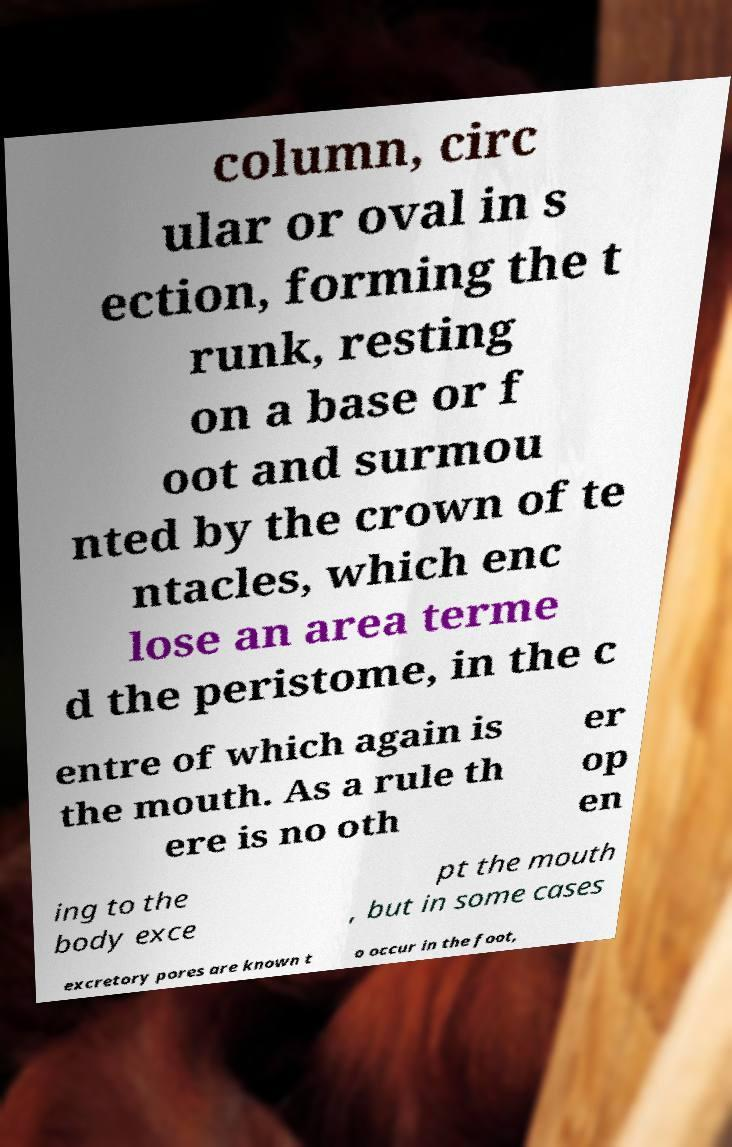Can you read and provide the text displayed in the image?This photo seems to have some interesting text. Can you extract and type it out for me? column, circ ular or oval in s ection, forming the t runk, resting on a base or f oot and surmou nted by the crown of te ntacles, which enc lose an area terme d the peristome, in the c entre of which again is the mouth. As a rule th ere is no oth er op en ing to the body exce pt the mouth , but in some cases excretory pores are known t o occur in the foot, 